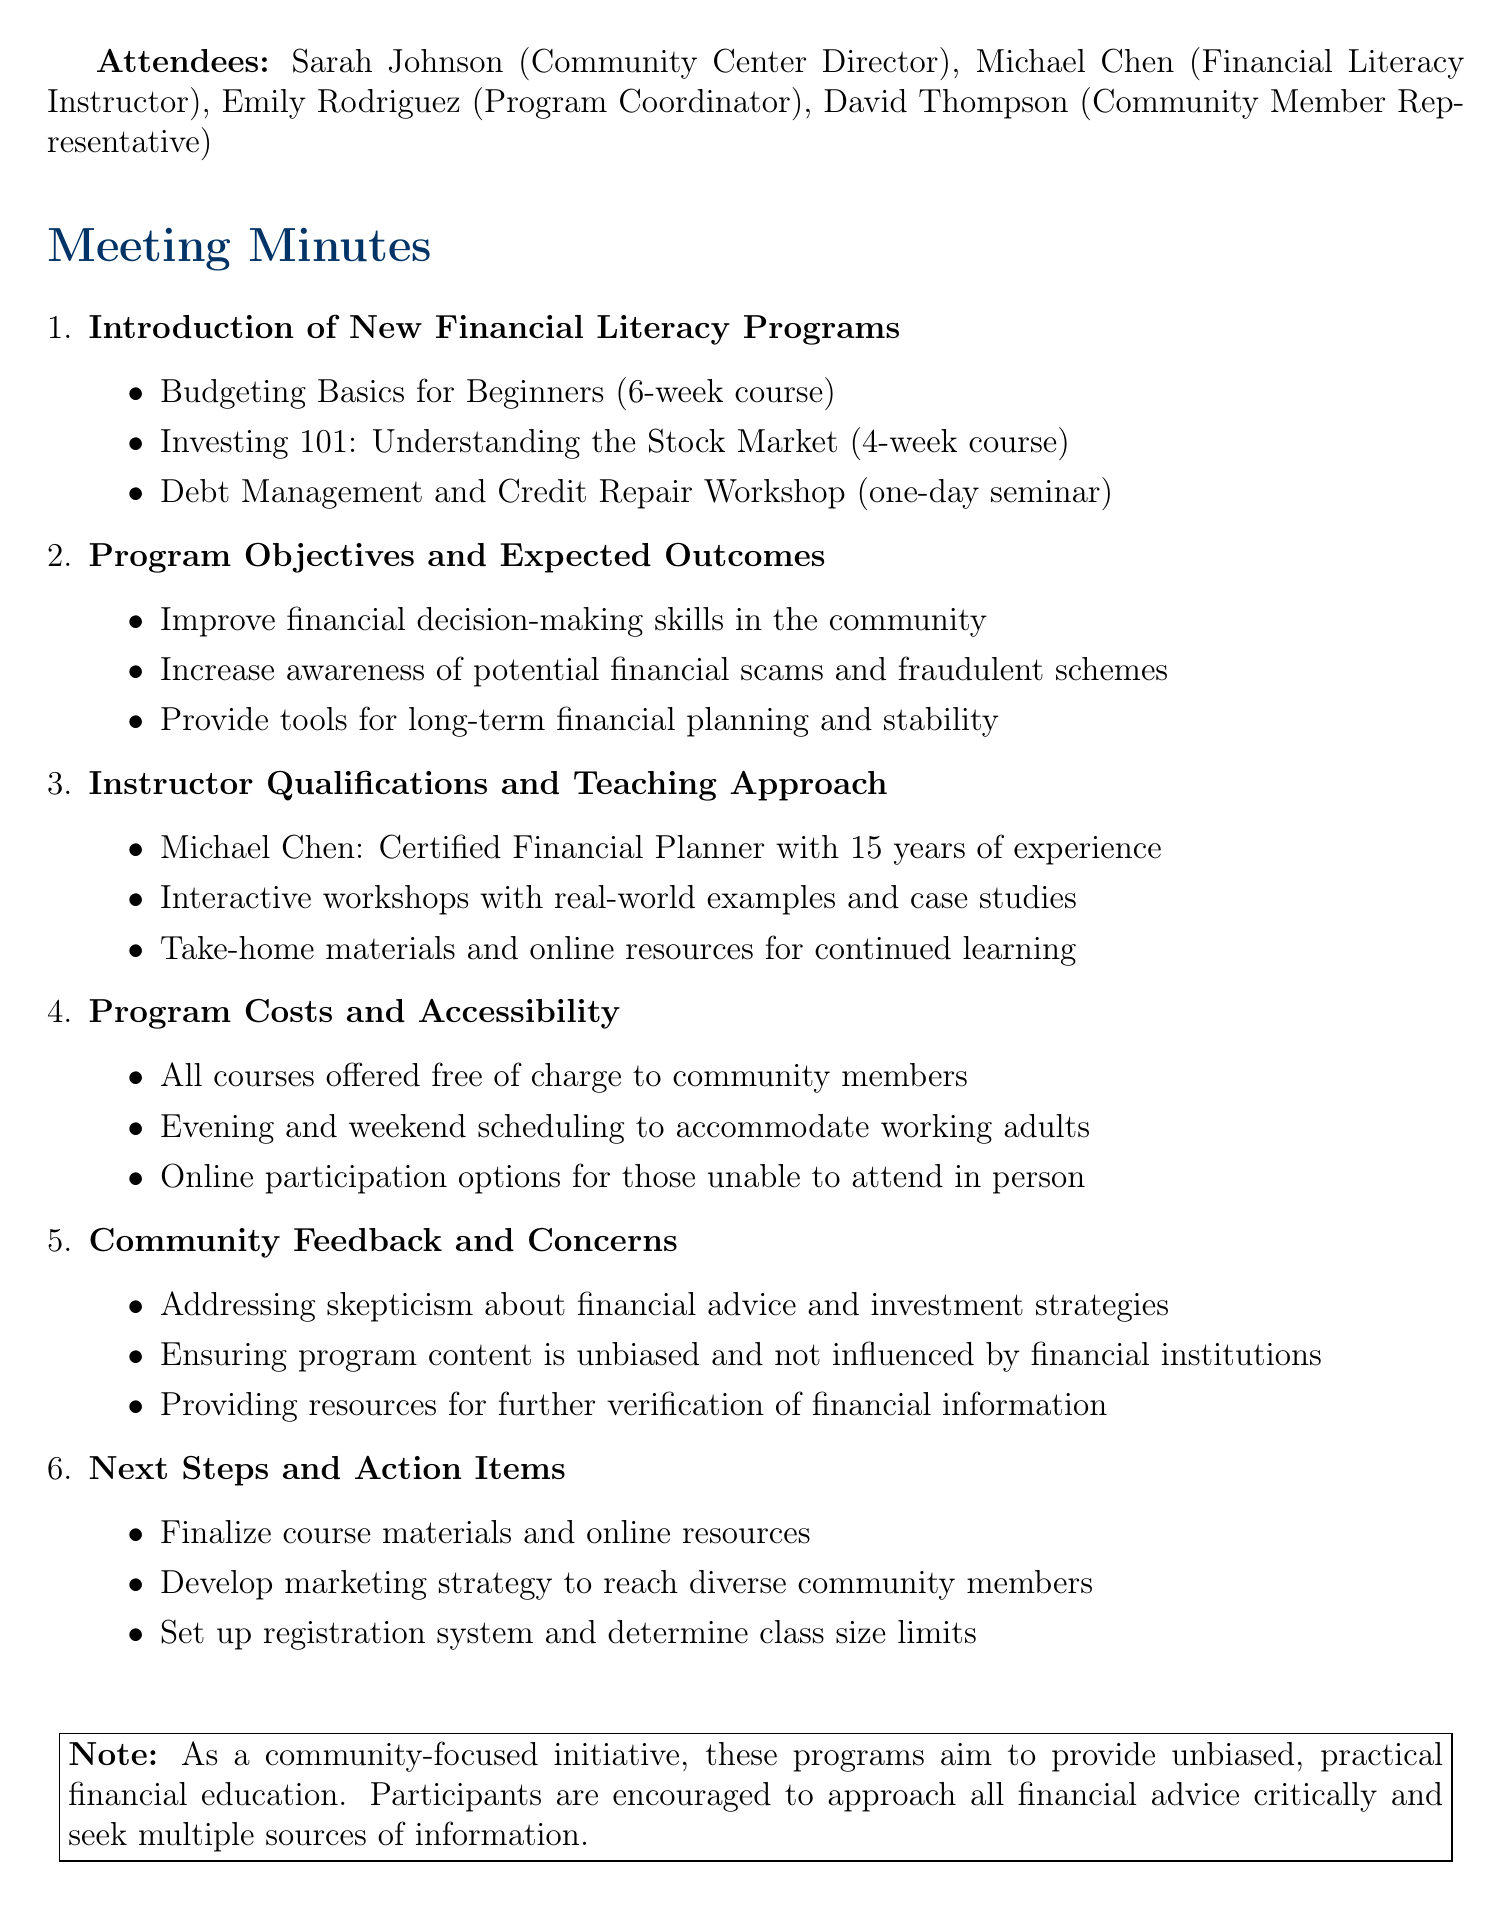what is the date of the meeting? The date of the meeting is mentioned in the document as May 15, 2023.
Answer: May 15, 2023 who is the financial literacy instructor? The document lists Michael Chen as the financial literacy instructor.
Answer: Michael Chen how long is the "Budgeting Basics for Beginners" course? The document states that the "Budgeting Basics for Beginners" course is a 6-week course.
Answer: 6-week course what is the expected outcome regarding financial scams? The document mentions that one of the expected outcomes is to increase awareness of potential financial scams and fraudulent schemes.
Answer: Increase awareness of potential financial scams are all courses offered free of charge? The document clearly states that all courses are offered free of charge to community members.
Answer: Free of charge what action item involves marketing? The action item related to marketing is to develop a marketing strategy to reach diverse community members.
Answer: Develop marketing strategy who is the representative of community members? David Thompson is identified as the community member representative in the document.
Answer: David Thompson what type of feedback was discussed? The document notes community feedback and concerns about skepticism toward financial advice and investment strategies.
Answer: Skepticism about financial advice how should participants approach financial advice? The document advises participants to approach all financial advice critically and seek multiple sources of information.
Answer: Critically and seek multiple sources 